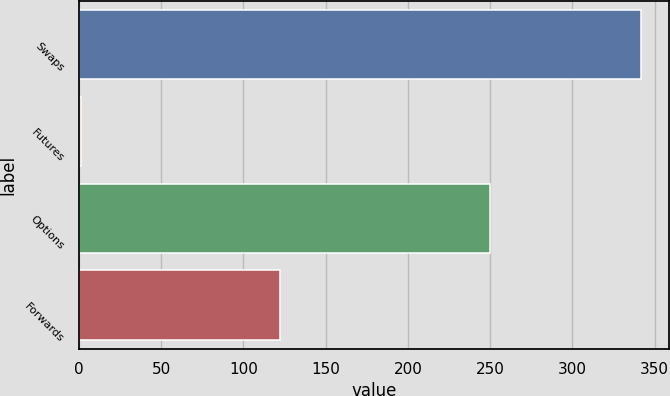Convert chart to OTSL. <chart><loc_0><loc_0><loc_500><loc_500><bar_chart><fcel>Swaps<fcel>Futures<fcel>Options<fcel>Forwards<nl><fcel>342<fcel>1<fcel>250<fcel>122<nl></chart> 